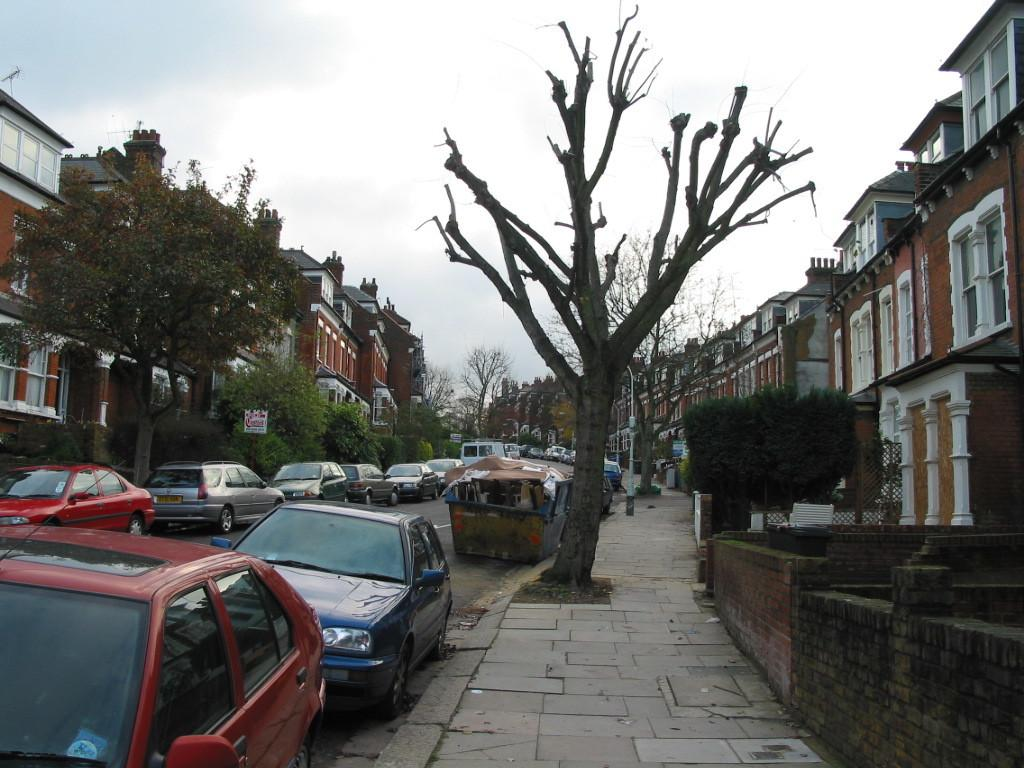What is the main feature of the image? There is a road in the image. What can be seen on the road? There are cars on the road. What type of vegetation is present on either side of the road? There are trees on either side of the road. What type of buildings are located on either side of the road? There are houses on either side of the road. Is there a parcel being delivered to the prison in the image? There is no prison or parcel delivery present in the image. 